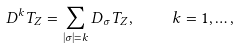Convert formula to latex. <formula><loc_0><loc_0><loc_500><loc_500>D ^ { k } T _ { Z } = \sum _ { | \sigma | = k } D _ { \sigma } T _ { Z } , \quad k = 1 , \dots ,</formula> 